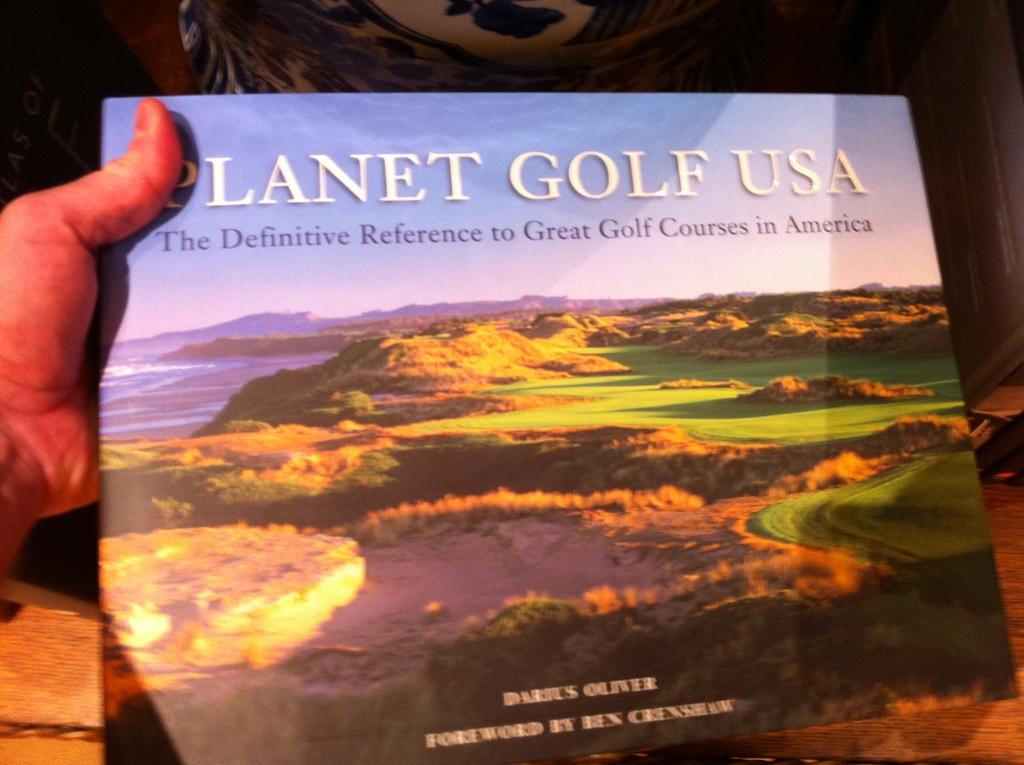Provide a one-sentence caption for the provided image. a book about golf called planer gold usa. 